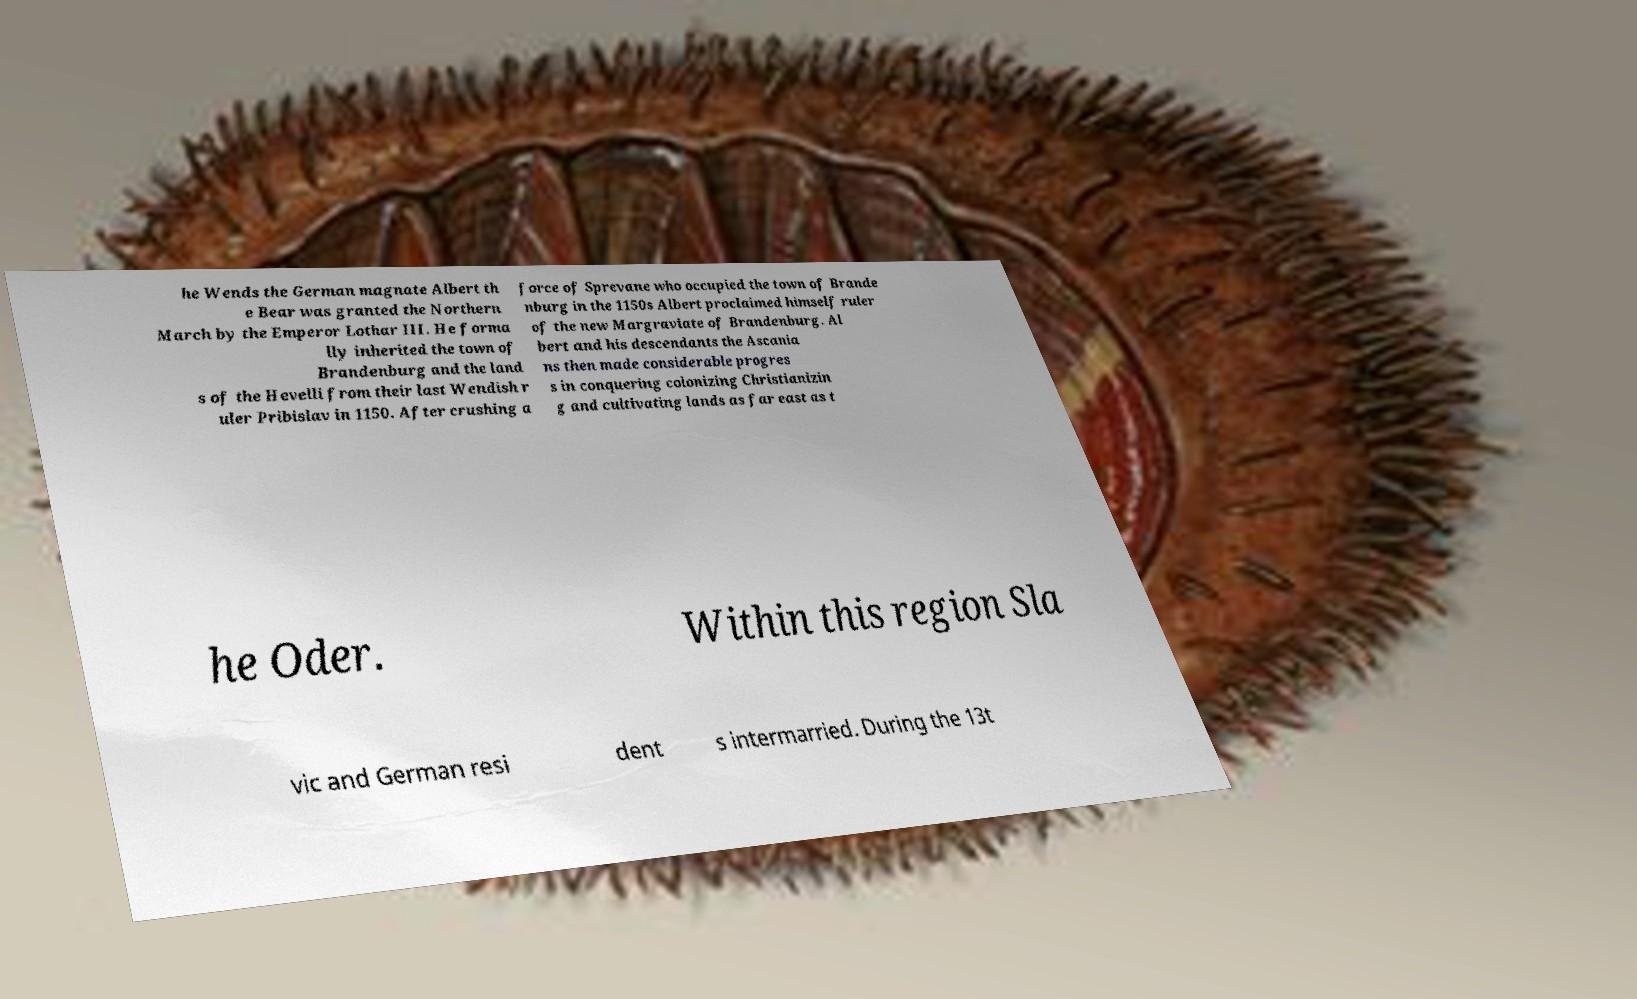Please read and relay the text visible in this image. What does it say? he Wends the German magnate Albert th e Bear was granted the Northern March by the Emperor Lothar III. He forma lly inherited the town of Brandenburg and the land s of the Hevelli from their last Wendish r uler Pribislav in 1150. After crushing a force of Sprevane who occupied the town of Brande nburg in the 1150s Albert proclaimed himself ruler of the new Margraviate of Brandenburg. Al bert and his descendants the Ascania ns then made considerable progres s in conquering colonizing Christianizin g and cultivating lands as far east as t he Oder. Within this region Sla vic and German resi dent s intermarried. During the 13t 